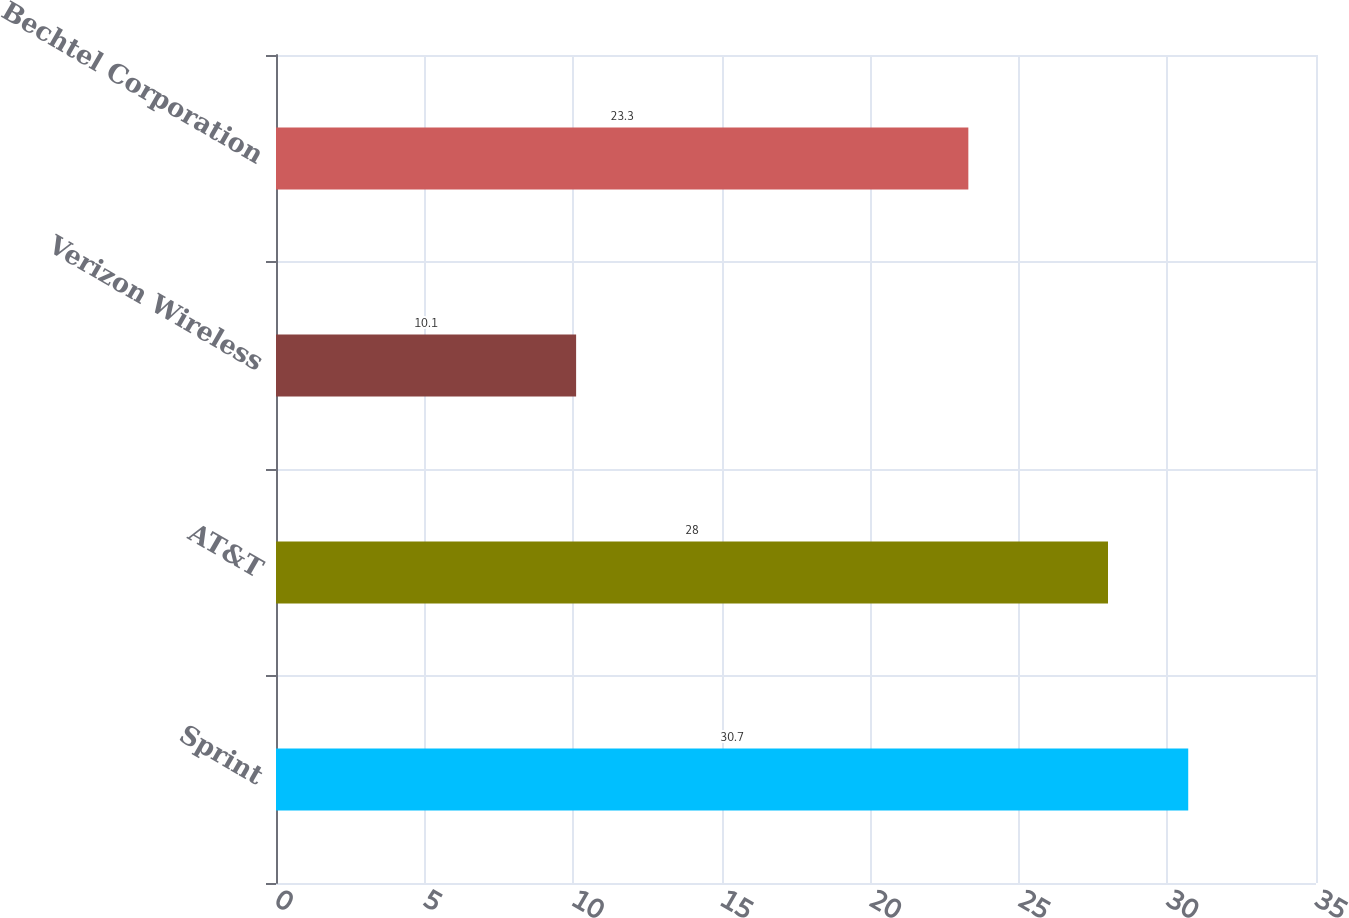Convert chart to OTSL. <chart><loc_0><loc_0><loc_500><loc_500><bar_chart><fcel>Sprint<fcel>AT&T<fcel>Verizon Wireless<fcel>Bechtel Corporation<nl><fcel>30.7<fcel>28<fcel>10.1<fcel>23.3<nl></chart> 